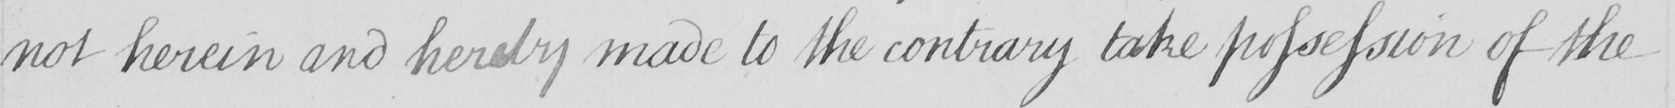Transcribe the text shown in this historical manuscript line. not herein and hereby made to the contrary take possession of the 